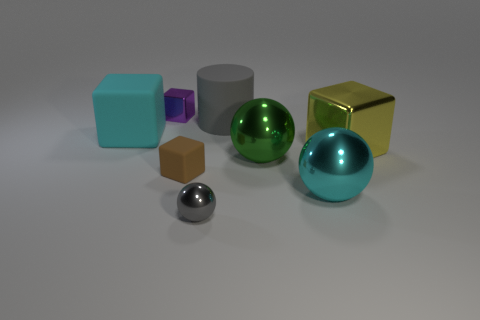Add 2 cylinders. How many objects exist? 10 Subtract all purple blocks. How many blocks are left? 3 Subtract all large yellow cubes. How many cubes are left? 3 Subtract 2 balls. How many balls are left? 1 Subtract 0 red spheres. How many objects are left? 8 Subtract all spheres. How many objects are left? 5 Subtract all cyan balls. Subtract all gray cylinders. How many balls are left? 2 Subtract all red cylinders. How many yellow spheres are left? 0 Subtract all cyan rubber spheres. Subtract all big green things. How many objects are left? 7 Add 7 yellow blocks. How many yellow blocks are left? 8 